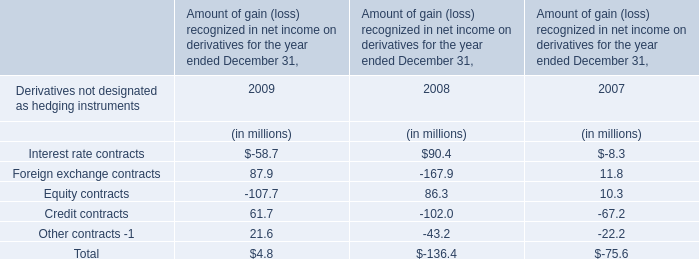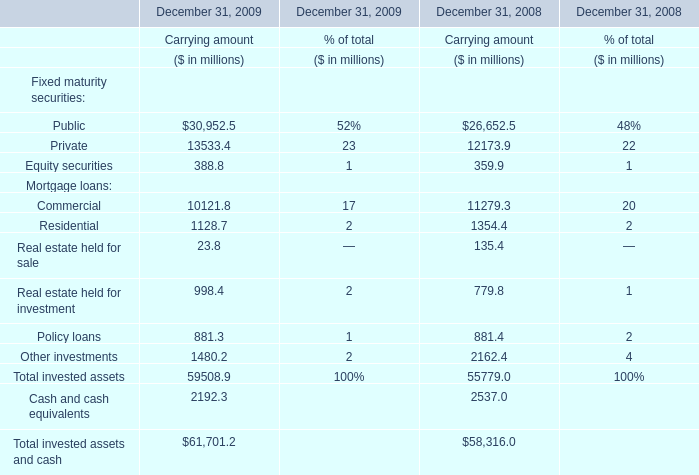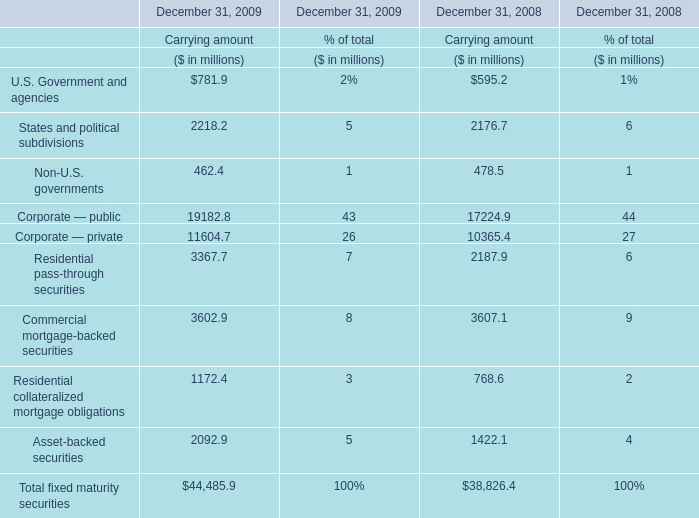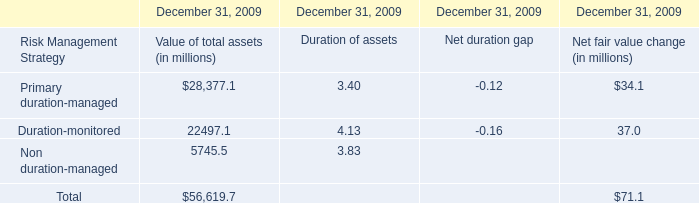What will Corporate — public for Carrying amount reach in 2010 if it continues to grow at its current rate? (in million) 
Computations: (11604.7 * ((11604.7 - 10365.4) / 10365.4))
Answer: 1387.47224. 